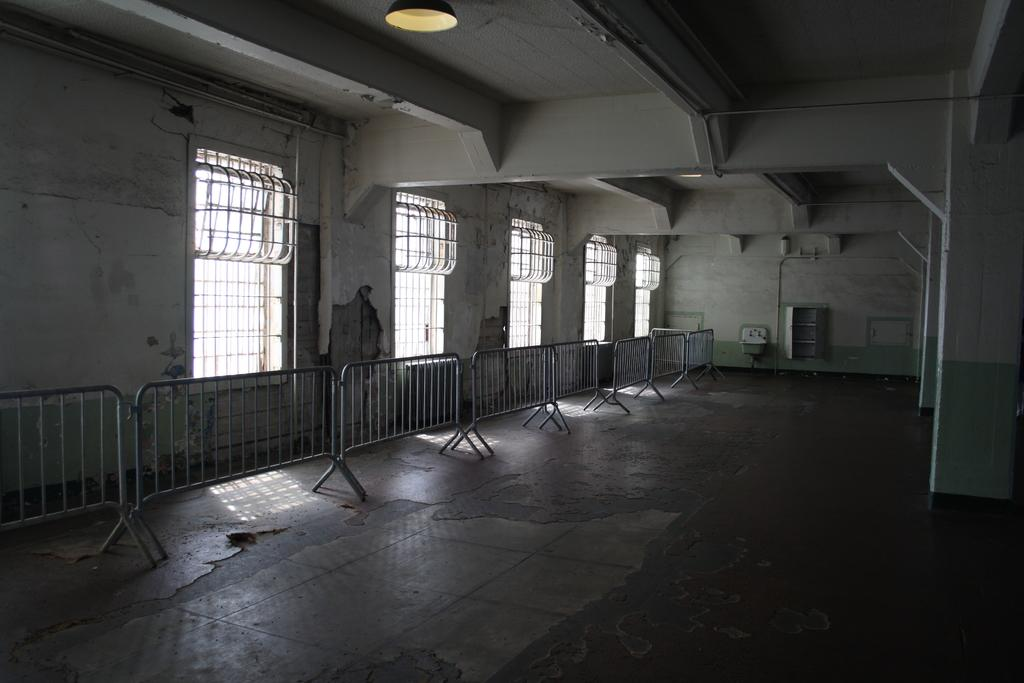What type of structure is shown in the image? There is a building in the image. What can be seen near the building? Grills and barrier poles are visible in the image. What type of architectural feature is present in the image? Walls are visible in the image. What type of boot is being worn by the crying person in the morning in the image? There is no person, crying or otherwise, wearing a boot in the image. 